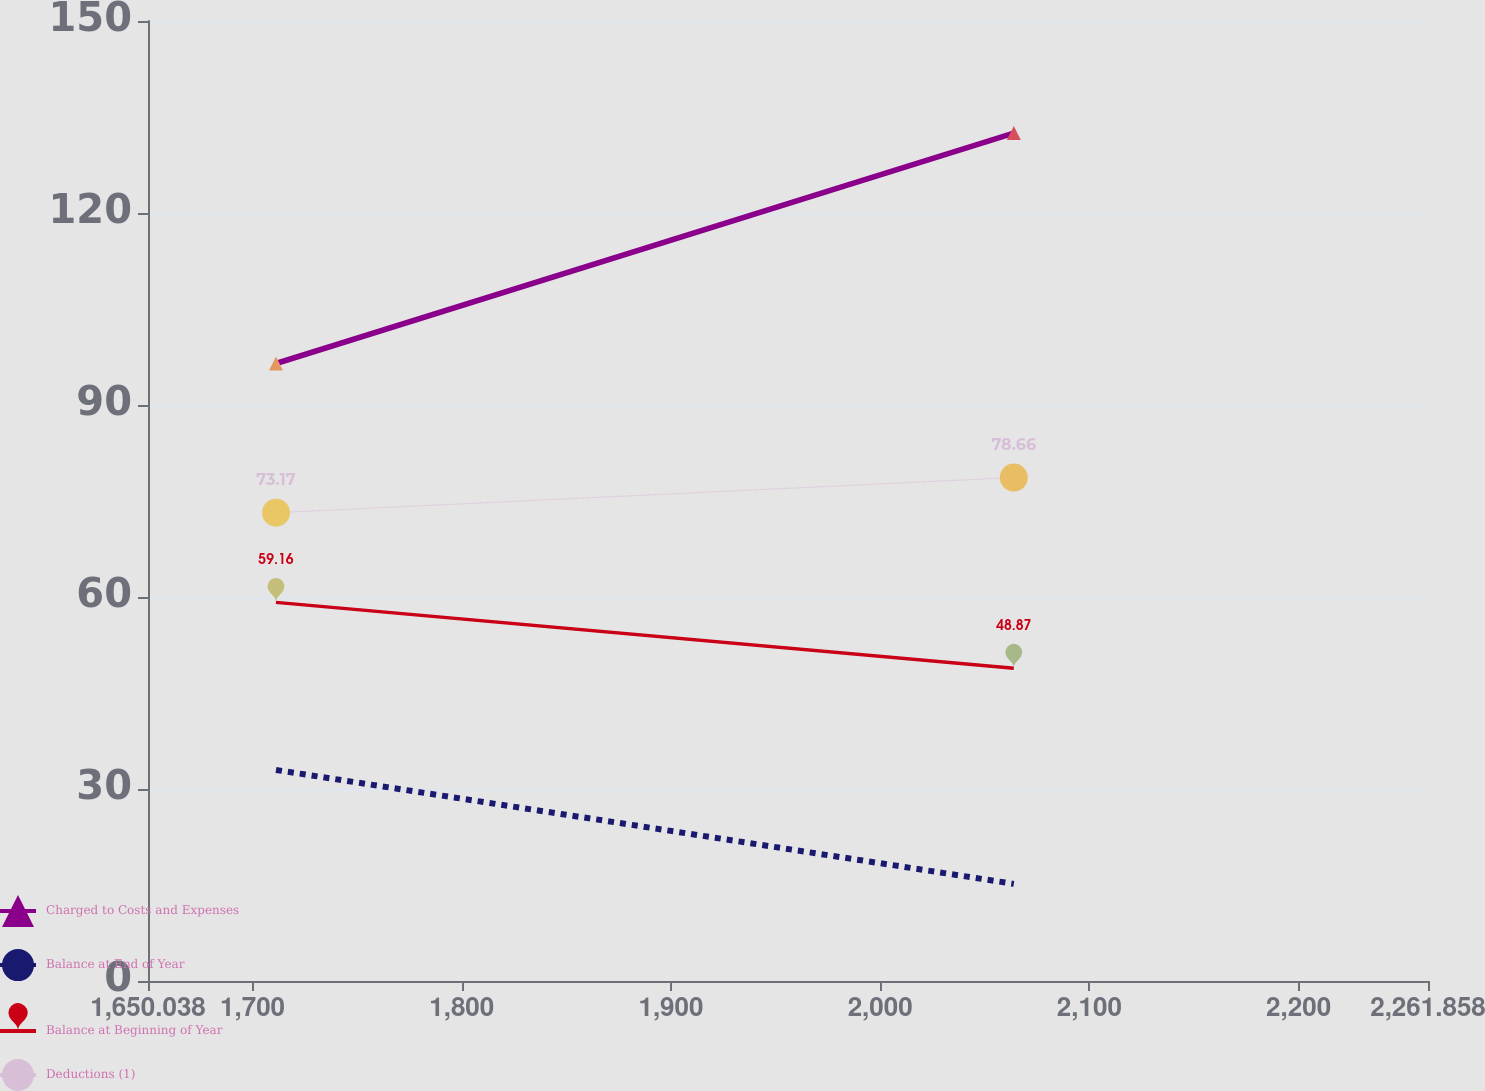<chart> <loc_0><loc_0><loc_500><loc_500><line_chart><ecel><fcel>Charged to Costs and Expenses<fcel>Balance at End of Year<fcel>Balance at Beginning of Year<fcel>Deductions (1)<nl><fcel>1711.22<fcel>96.49<fcel>32.97<fcel>59.16<fcel>73.17<nl><fcel>2063.88<fcel>132.49<fcel>15.18<fcel>48.87<fcel>78.66<nl><fcel>2323.04<fcel>108.63<fcel>58.2<fcel>40.61<fcel>116.11<nl></chart> 